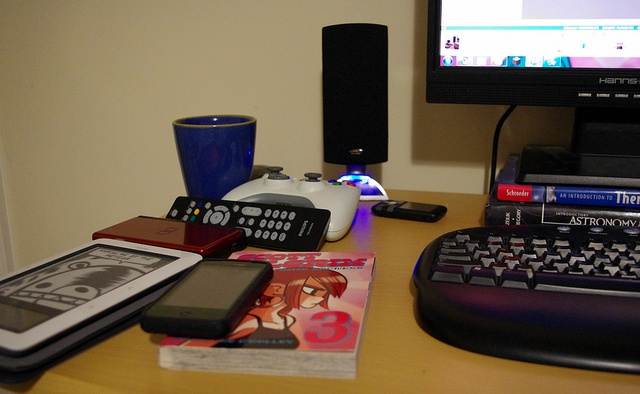Describe the objects in this image and their specific colors. I can see keyboard in gray and black tones, tv in gray, white, black, violet, and lightblue tones, book in gray, brown, and maroon tones, cell phone in gray, black, and darkgray tones, and cell phone in gray and black tones in this image. 